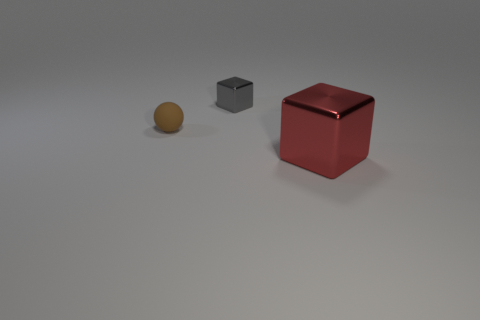There is a metal object that is the same size as the brown rubber ball; what is its shape?
Offer a terse response. Cube. There is a object that is both right of the brown object and in front of the gray metal object; how big is it?
Offer a very short reply. Large. Is the number of small things right of the small gray thing greater than the number of rubber balls right of the ball?
Offer a terse response. No. What is the color of the object that is on the right side of the matte object and on the left side of the large metal cube?
Your answer should be very brief. Gray. There is another metal thing that is the same shape as the large red thing; what is its size?
Your response must be concise. Small. Do the small shiny block and the rubber sphere have the same color?
Provide a short and direct response. No. Are there an equal number of small metal things that are on the right side of the big metallic object and metal cubes?
Your answer should be very brief. No. There is a object behind the brown rubber sphere; is its size the same as the small brown sphere?
Offer a terse response. Yes. What number of tiny spheres are in front of the large red cube?
Provide a short and direct response. 0. What is the material of the thing that is in front of the gray block and left of the large shiny block?
Offer a very short reply. Rubber. 